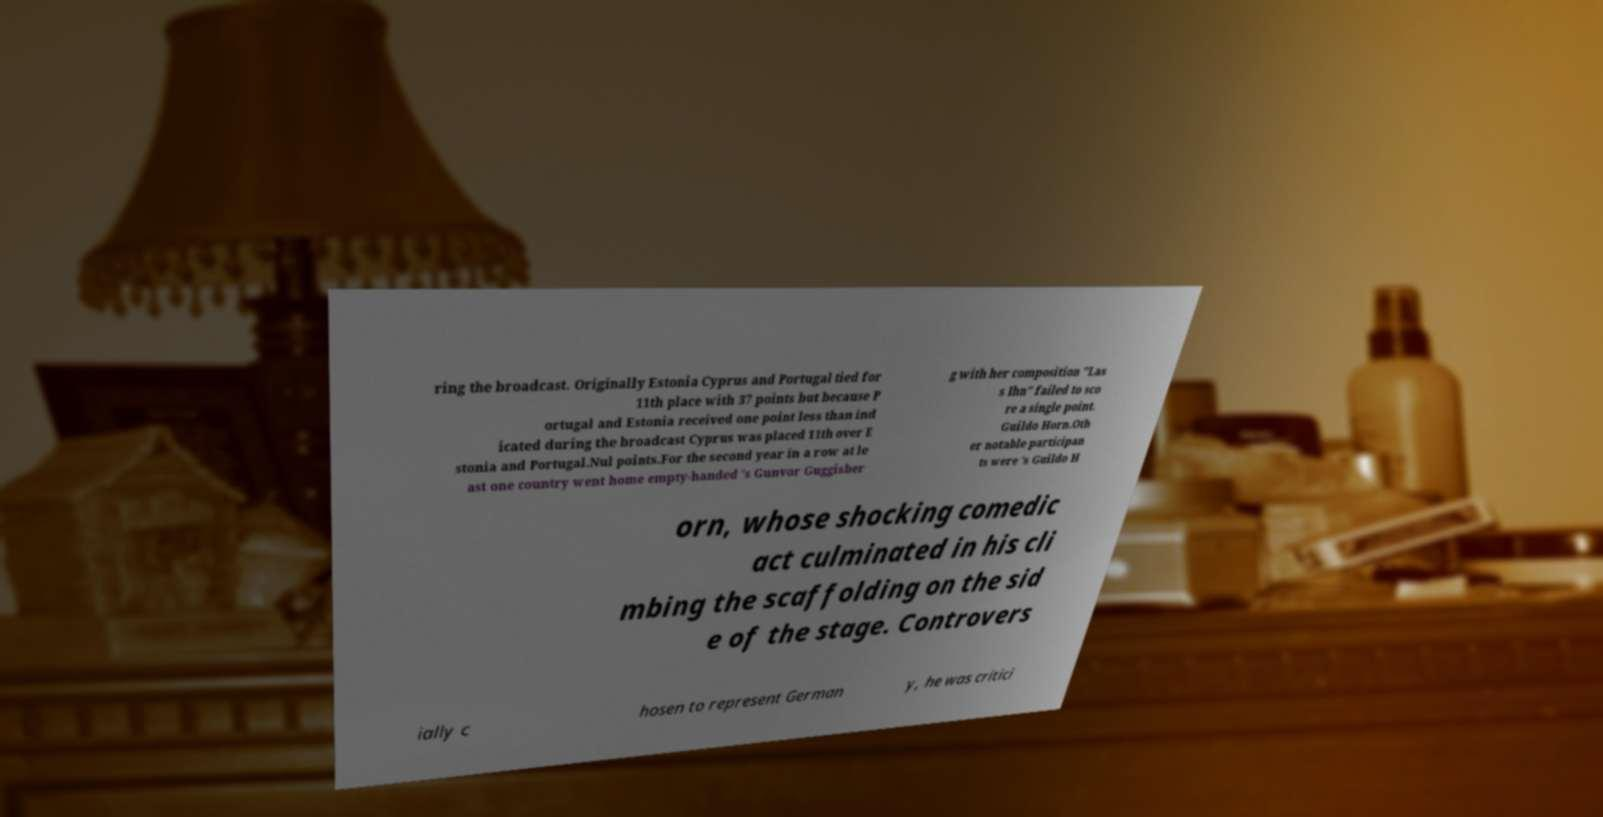Could you assist in decoding the text presented in this image and type it out clearly? ring the broadcast. Originally Estonia Cyprus and Portugal tied for 11th place with 37 points but because P ortugal and Estonia received one point less than ind icated during the broadcast Cyprus was placed 11th over E stonia and Portugal.Nul points.For the second year in a row at le ast one country went home empty-handed 's Gunvor Guggisber g with her composition "Las s Ihn" failed to sco re a single point. Guildo Horn.Oth er notable participan ts were 's Guildo H orn, whose shocking comedic act culminated in his cli mbing the scaffolding on the sid e of the stage. Controvers ially c hosen to represent German y, he was critici 